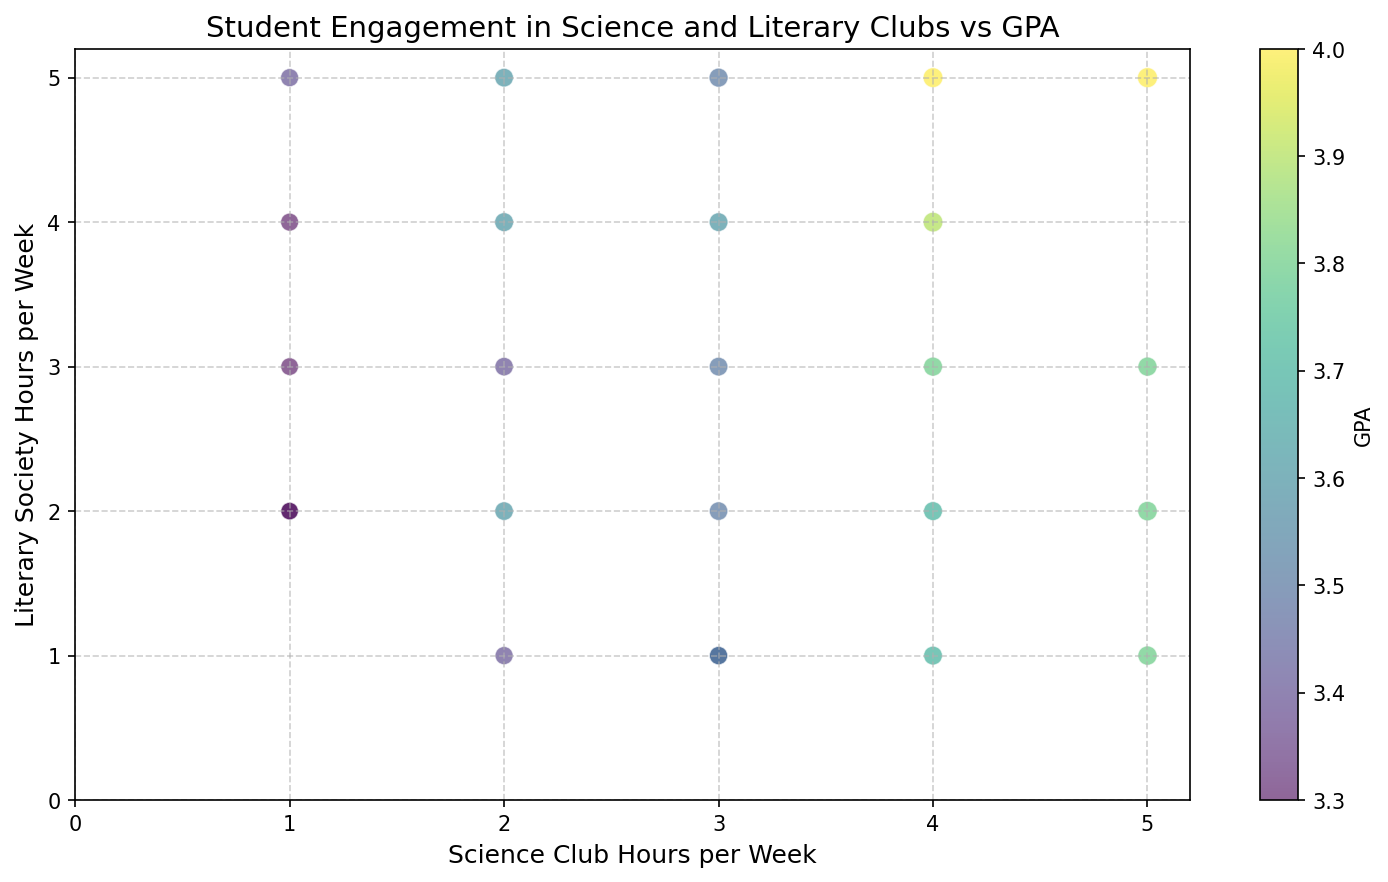How many students spend more than 3 hours per week in both science clubs and literary societies? Look for data points where both the x-axis (science club hours) and y-axis (literary society hours) values are greater than 3.
Answer: 5 What is the highest GPA recorded, and what are the corresponding hours spent in science clubs and literary societies? Identify the color corresponding to the highest GPA value in the colorbar, then find the data point with that color. Check the x and y values for that data point.
Answer: 4.0, 5 hours in both clubs Which student has the highest engagement score, and how many hours do they spend in science and literary societies? Find the largest bubble (since engagement score is represented by the bubble size), then check its x and y values.
Answer: 21, 5 hours in both clubs Is there any student who spends equal time in both science clubs and literary societies and has a GPA of 3.8? Look for data points on the line y = x with a color corresponding to a GPA of 3.8 as per the colorbar.
Answer: Yes What GPA range corresponds to students who spend 2 hours per week in science clubs? Look at all data points where the x-value is 2, and then check the colors relative to the GPA colorbar.
Answer: 3.4 to 3.6 How many students have a student engagement score greater than 8 and over 4 science club hours per week? Identify data points with large-sized bubbles (>8 engagement score) and check if the x-value is greater than 4. Count these data points.
Answer: 2 Are there more students with GPAs above 3.7 spending more time in literary societies or science clubs? Look at bubbles colored for GPA > 3.7 and compare their y-values (literary societies) and x-values (science clubs).
Answer: Science clubs What's the average GPA for students with 3 hours per week in science clubs? Identify all data points with x-values of 3, sum their GPA values, and divide by the count of these points.
Answer: 3.55 What is the most common engagement score range for students spending 4 hours in both clubs? Identify data points where x = 4 and y = 4, then look at the bubble sizes for these points and note the range they fall into.
Answer: 8.9 to 9.0 